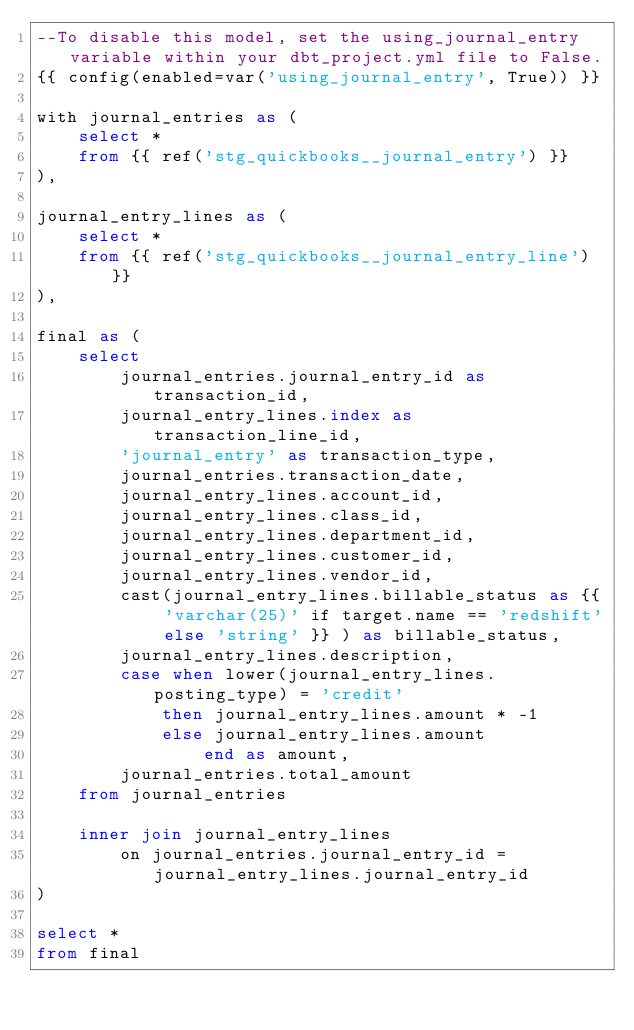Convert code to text. <code><loc_0><loc_0><loc_500><loc_500><_SQL_>--To disable this model, set the using_journal_entry variable within your dbt_project.yml file to False.
{{ config(enabled=var('using_journal_entry', True)) }}

with journal_entries as (
    select *
    from {{ ref('stg_quickbooks__journal_entry') }}
),

journal_entry_lines as (
    select *
    from {{ ref('stg_quickbooks__journal_entry_line') }}
),

final as (
    select
        journal_entries.journal_entry_id as transaction_id,
        journal_entry_lines.index as transaction_line_id,
        'journal_entry' as transaction_type,
        journal_entries.transaction_date,
        journal_entry_lines.account_id,
        journal_entry_lines.class_id,
        journal_entry_lines.department_id,
        journal_entry_lines.customer_id,
        journal_entry_lines.vendor_id,
        cast(journal_entry_lines.billable_status as {{ 'varchar(25)' if target.name == 'redshift' else 'string' }} ) as billable_status,
        journal_entry_lines.description,
        case when lower(journal_entry_lines.posting_type) = 'credit'
            then journal_entry_lines.amount * -1 
            else journal_entry_lines.amount 
                end as amount,
        journal_entries.total_amount
    from journal_entries

    inner join journal_entry_lines
        on journal_entries.journal_entry_id = journal_entry_lines.journal_entry_id
)

select *
from final</code> 